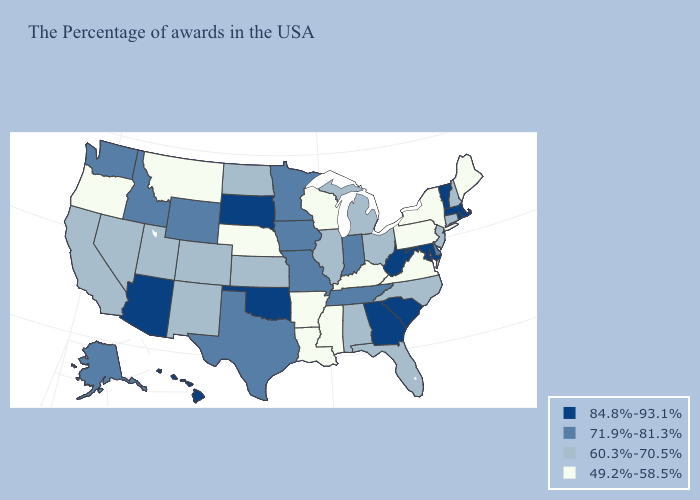Among the states that border Minnesota , does Wisconsin have the highest value?
Keep it brief. No. Does New Jersey have the same value as Montana?
Quick response, please. No. What is the highest value in states that border Virginia?
Concise answer only. 84.8%-93.1%. Which states have the lowest value in the South?
Short answer required. Virginia, Kentucky, Mississippi, Louisiana, Arkansas. What is the highest value in the USA?
Answer briefly. 84.8%-93.1%. Name the states that have a value in the range 84.8%-93.1%?
Concise answer only. Massachusetts, Rhode Island, Vermont, Maryland, South Carolina, West Virginia, Georgia, Oklahoma, South Dakota, Arizona, Hawaii. Name the states that have a value in the range 49.2%-58.5%?
Concise answer only. Maine, New York, Pennsylvania, Virginia, Kentucky, Wisconsin, Mississippi, Louisiana, Arkansas, Nebraska, Montana, Oregon. Among the states that border Mississippi , which have the lowest value?
Short answer required. Louisiana, Arkansas. Among the states that border New Jersey , does New York have the lowest value?
Write a very short answer. Yes. Among the states that border Maryland , does Delaware have the highest value?
Concise answer only. No. What is the lowest value in the USA?
Write a very short answer. 49.2%-58.5%. What is the value of Connecticut?
Concise answer only. 60.3%-70.5%. Among the states that border South Dakota , does Iowa have the lowest value?
Write a very short answer. No. Name the states that have a value in the range 84.8%-93.1%?
Concise answer only. Massachusetts, Rhode Island, Vermont, Maryland, South Carolina, West Virginia, Georgia, Oklahoma, South Dakota, Arizona, Hawaii. Does Connecticut have the lowest value in the Northeast?
Short answer required. No. 